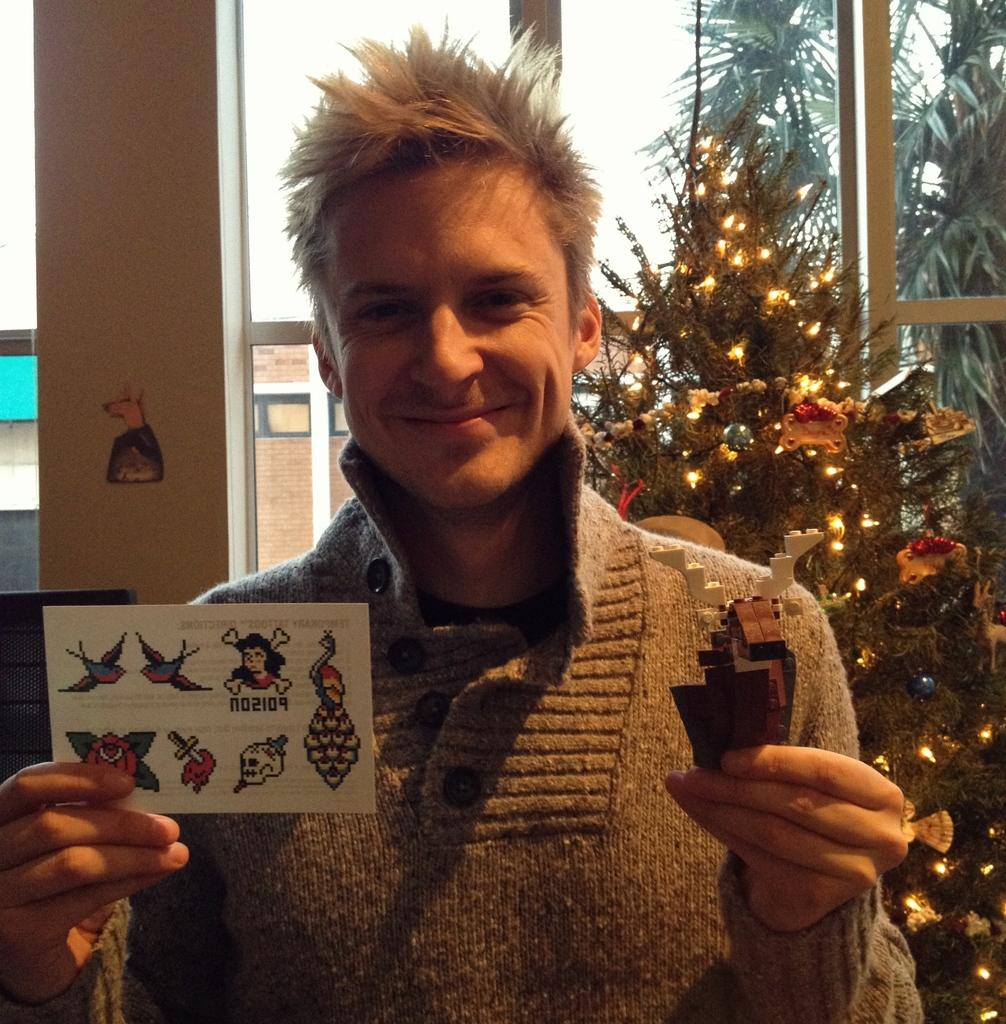Who is present in the image? There is a man in the image. What is the man holding in his hands? The man is holding a card and a craft. What can be seen in the background of the image? There is a Xmas tree, a pillar, and windows in the background of the image. What is visible through the windows? Trees are visible through the windows. What is the name of the basin that the man is using in the image? There is no basin present in the image. How does the man show respect to the craft in the image? The image does not show any indication of the man showing respect to the craft. 